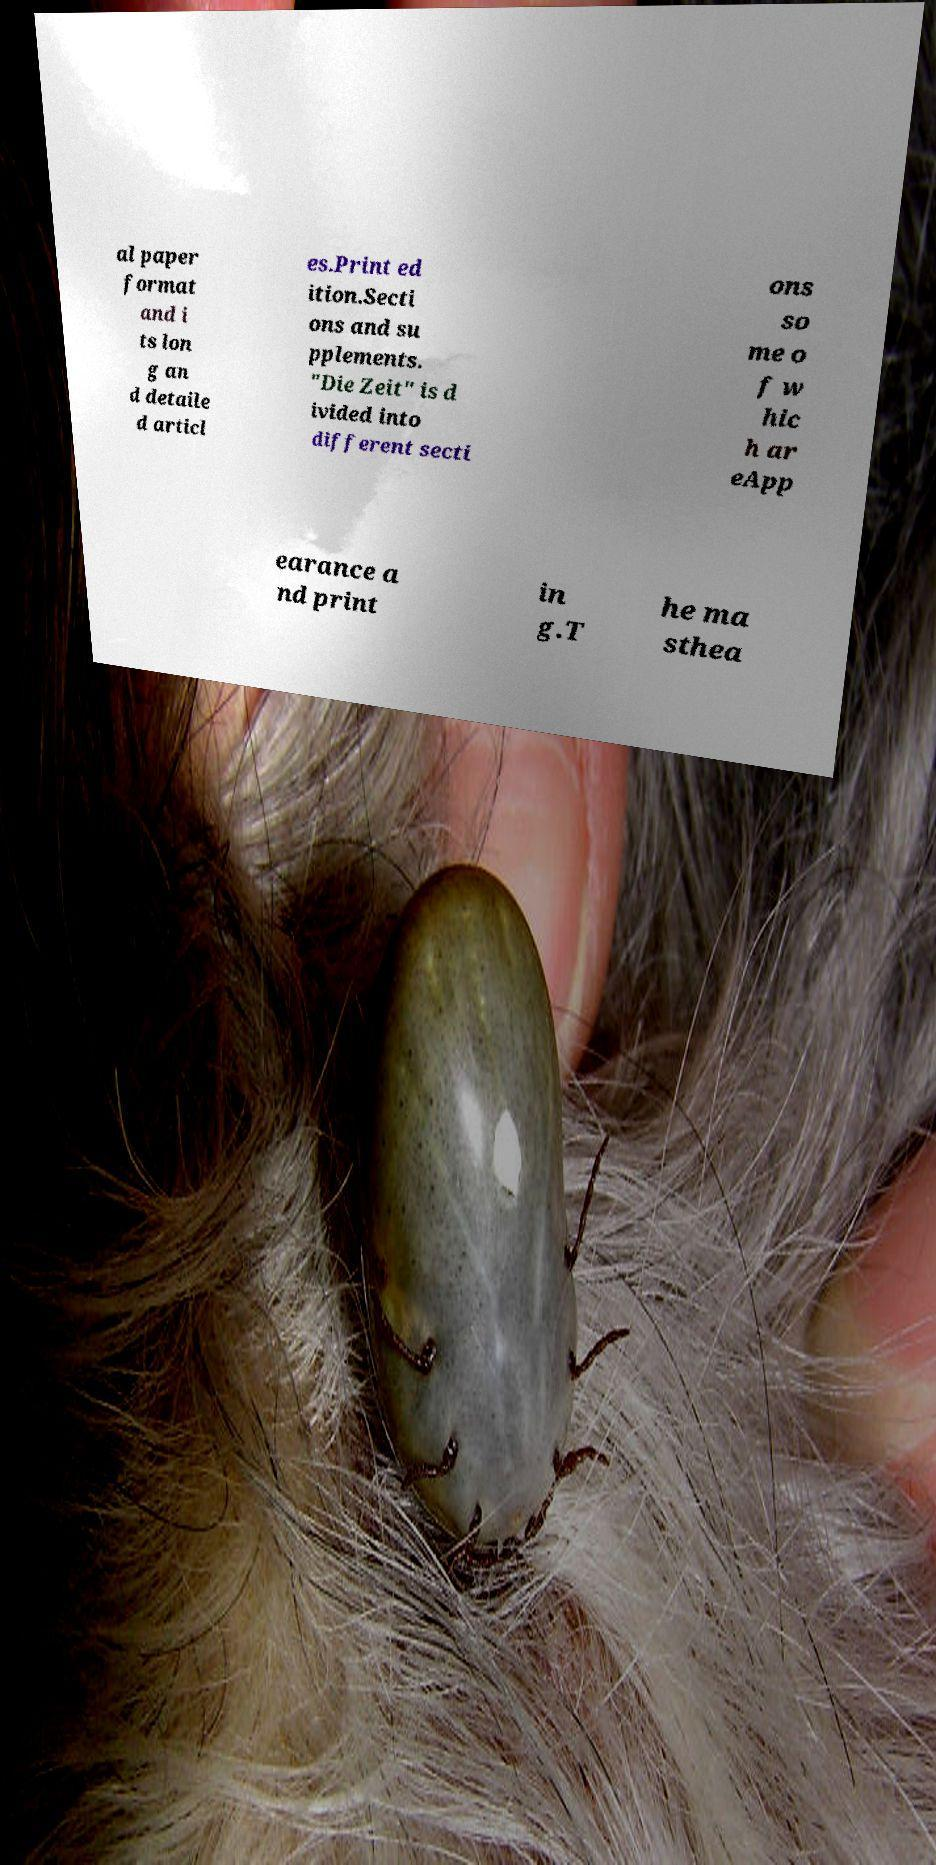Can you read and provide the text displayed in the image?This photo seems to have some interesting text. Can you extract and type it out for me? al paper format and i ts lon g an d detaile d articl es.Print ed ition.Secti ons and su pplements. "Die Zeit" is d ivided into different secti ons so me o f w hic h ar eApp earance a nd print in g.T he ma sthea 